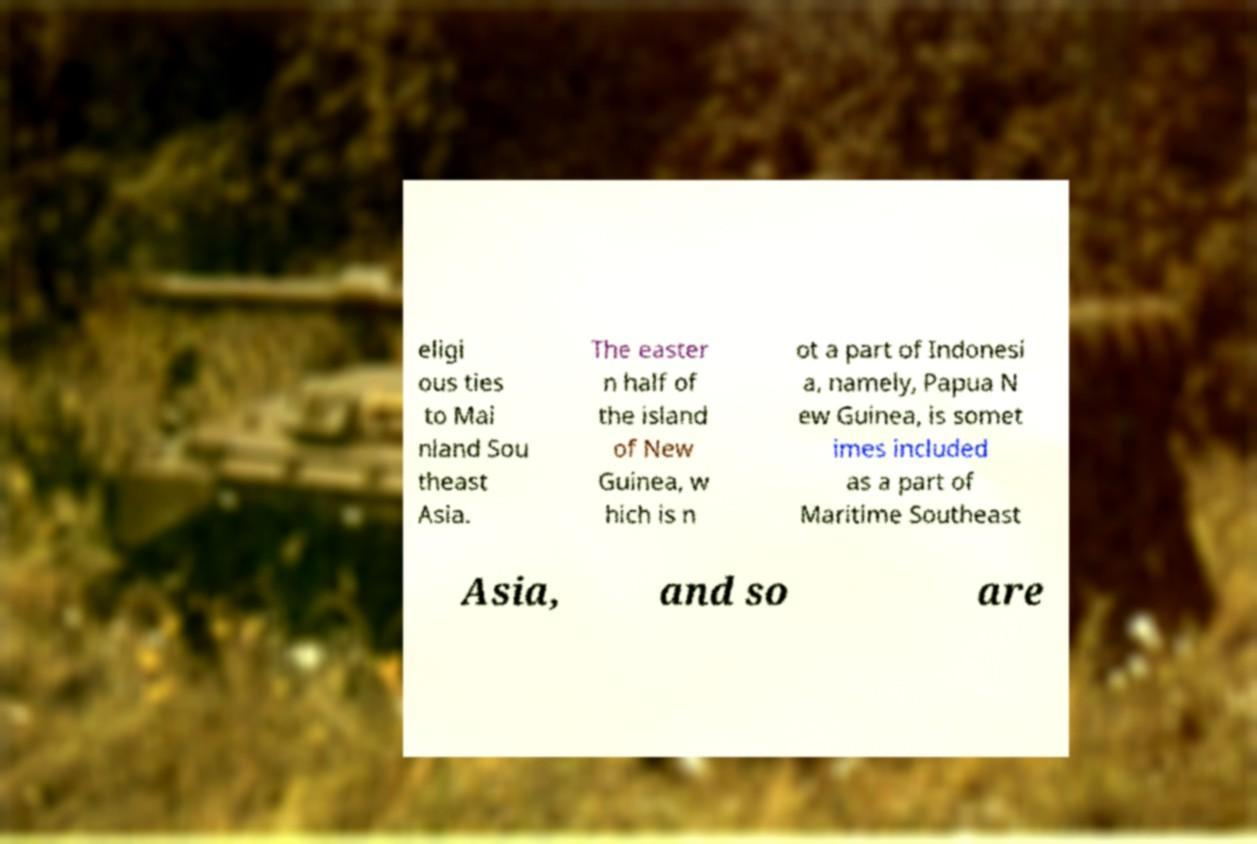What messages or text are displayed in this image? I need them in a readable, typed format. eligi ous ties to Mai nland Sou theast Asia. The easter n half of the island of New Guinea, w hich is n ot a part of Indonesi a, namely, Papua N ew Guinea, is somet imes included as a part of Maritime Southeast Asia, and so are 